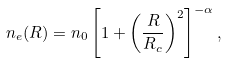Convert formula to latex. <formula><loc_0><loc_0><loc_500><loc_500>n _ { e } ( R ) = n _ { 0 } \left [ 1 + \left ( \frac { R } { R _ { c } } \right ) ^ { 2 } \right ] ^ { - \alpha } ,</formula> 